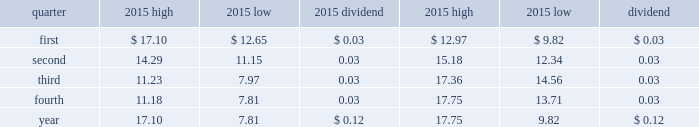Part ii item 5 .
Market for registrant 2019s common equity , related stockholder matters and issuer purchases of equity securities .
The company 2019s common stock is listed on the new york stock exchange where it trades under the symbol aa .
The company 2019s quarterly high and low trading stock prices and dividends per common share for 2015 and 2014 are shown below. .
The number of holders of record of common stock was approximately 10101 as of february 11 , 2016. .
What is the decrease observed in the high trading stock prices in the first and second quarters in 2015? 
Rationale: it is the difference between those two prices .
Computations: (17.10 - 14.29)
Answer: 2.81. 